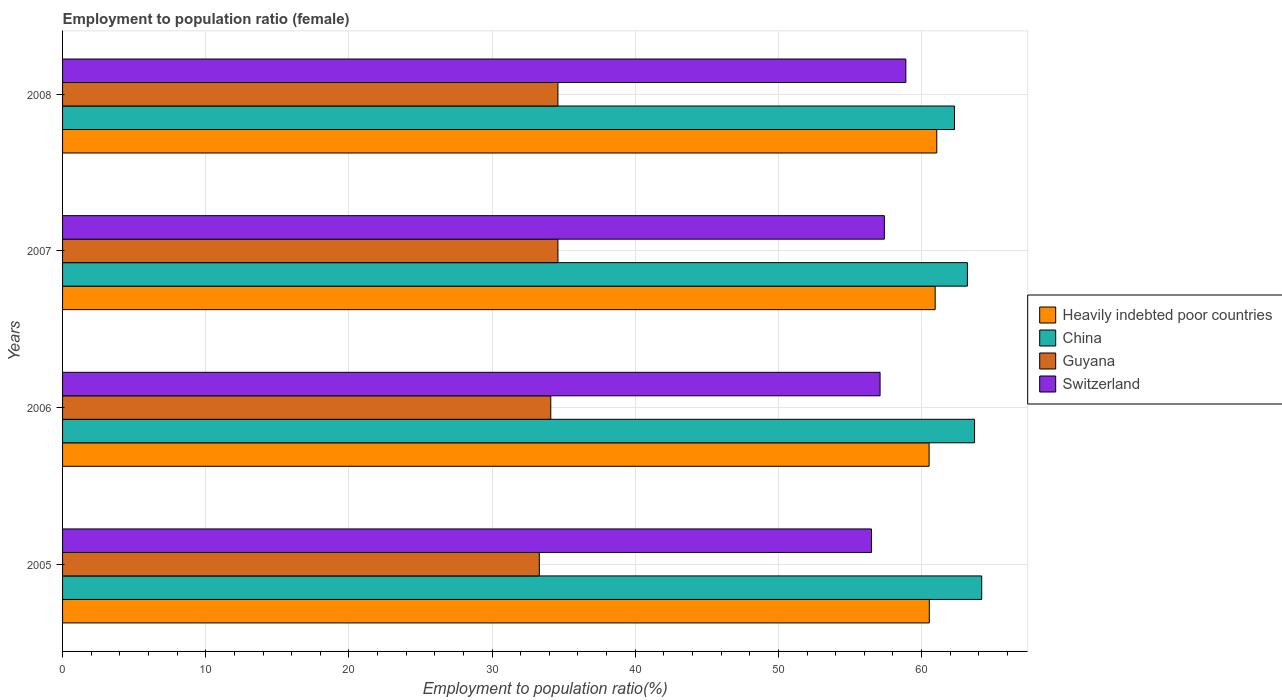How many groups of bars are there?
Provide a short and direct response. 4. Are the number of bars per tick equal to the number of legend labels?
Offer a very short reply. Yes. How many bars are there on the 4th tick from the top?
Your answer should be very brief. 4. What is the employment to population ratio in Guyana in 2007?
Your answer should be very brief. 34.6. Across all years, what is the maximum employment to population ratio in Guyana?
Your answer should be compact. 34.6. Across all years, what is the minimum employment to population ratio in Guyana?
Make the answer very short. 33.3. In which year was the employment to population ratio in Heavily indebted poor countries maximum?
Ensure brevity in your answer.  2008. What is the total employment to population ratio in Switzerland in the graph?
Provide a short and direct response. 229.9. What is the difference between the employment to population ratio in Heavily indebted poor countries in 2005 and that in 2008?
Offer a terse response. -0.52. What is the difference between the employment to population ratio in Guyana in 2005 and the employment to population ratio in Heavily indebted poor countries in 2007?
Ensure brevity in your answer.  -27.65. What is the average employment to population ratio in China per year?
Provide a short and direct response. 63.35. In the year 2007, what is the difference between the employment to population ratio in China and employment to population ratio in Guyana?
Give a very brief answer. 28.6. What is the ratio of the employment to population ratio in Switzerland in 2006 to that in 2007?
Provide a succinct answer. 0.99. Is the employment to population ratio in Guyana in 2006 less than that in 2008?
Make the answer very short. Yes. Is the difference between the employment to population ratio in China in 2006 and 2008 greater than the difference between the employment to population ratio in Guyana in 2006 and 2008?
Provide a short and direct response. Yes. What is the difference between the highest and the second highest employment to population ratio in Heavily indebted poor countries?
Your response must be concise. 0.11. What is the difference between the highest and the lowest employment to population ratio in Switzerland?
Ensure brevity in your answer.  2.4. In how many years, is the employment to population ratio in China greater than the average employment to population ratio in China taken over all years?
Your answer should be compact. 2. Is the sum of the employment to population ratio in China in 2006 and 2008 greater than the maximum employment to population ratio in Heavily indebted poor countries across all years?
Provide a succinct answer. Yes. Is it the case that in every year, the sum of the employment to population ratio in Guyana and employment to population ratio in China is greater than the sum of employment to population ratio in Switzerland and employment to population ratio in Heavily indebted poor countries?
Keep it short and to the point. Yes. What does the 2nd bar from the top in 2008 represents?
Your answer should be compact. Guyana. What does the 4th bar from the bottom in 2008 represents?
Provide a short and direct response. Switzerland. How many bars are there?
Offer a terse response. 16. Are all the bars in the graph horizontal?
Your response must be concise. Yes. How many years are there in the graph?
Provide a short and direct response. 4. Are the values on the major ticks of X-axis written in scientific E-notation?
Give a very brief answer. No. Does the graph contain grids?
Your answer should be very brief. Yes. What is the title of the graph?
Provide a short and direct response. Employment to population ratio (female). What is the label or title of the Y-axis?
Ensure brevity in your answer.  Years. What is the Employment to population ratio(%) of Heavily indebted poor countries in 2005?
Provide a short and direct response. 60.54. What is the Employment to population ratio(%) of China in 2005?
Keep it short and to the point. 64.2. What is the Employment to population ratio(%) of Guyana in 2005?
Your answer should be compact. 33.3. What is the Employment to population ratio(%) of Switzerland in 2005?
Keep it short and to the point. 56.5. What is the Employment to population ratio(%) in Heavily indebted poor countries in 2006?
Make the answer very short. 60.52. What is the Employment to population ratio(%) of China in 2006?
Provide a succinct answer. 63.7. What is the Employment to population ratio(%) of Guyana in 2006?
Ensure brevity in your answer.  34.1. What is the Employment to population ratio(%) in Switzerland in 2006?
Your answer should be compact. 57.1. What is the Employment to population ratio(%) of Heavily indebted poor countries in 2007?
Keep it short and to the point. 60.95. What is the Employment to population ratio(%) in China in 2007?
Your answer should be very brief. 63.2. What is the Employment to population ratio(%) of Guyana in 2007?
Provide a succinct answer. 34.6. What is the Employment to population ratio(%) of Switzerland in 2007?
Offer a very short reply. 57.4. What is the Employment to population ratio(%) in Heavily indebted poor countries in 2008?
Keep it short and to the point. 61.06. What is the Employment to population ratio(%) of China in 2008?
Your answer should be very brief. 62.3. What is the Employment to population ratio(%) of Guyana in 2008?
Give a very brief answer. 34.6. What is the Employment to population ratio(%) of Switzerland in 2008?
Offer a very short reply. 58.9. Across all years, what is the maximum Employment to population ratio(%) of Heavily indebted poor countries?
Offer a terse response. 61.06. Across all years, what is the maximum Employment to population ratio(%) of China?
Ensure brevity in your answer.  64.2. Across all years, what is the maximum Employment to population ratio(%) of Guyana?
Offer a terse response. 34.6. Across all years, what is the maximum Employment to population ratio(%) in Switzerland?
Offer a very short reply. 58.9. Across all years, what is the minimum Employment to population ratio(%) in Heavily indebted poor countries?
Your answer should be compact. 60.52. Across all years, what is the minimum Employment to population ratio(%) in China?
Your response must be concise. 62.3. Across all years, what is the minimum Employment to population ratio(%) in Guyana?
Your answer should be very brief. 33.3. Across all years, what is the minimum Employment to population ratio(%) of Switzerland?
Your answer should be compact. 56.5. What is the total Employment to population ratio(%) of Heavily indebted poor countries in the graph?
Your response must be concise. 243.07. What is the total Employment to population ratio(%) of China in the graph?
Give a very brief answer. 253.4. What is the total Employment to population ratio(%) in Guyana in the graph?
Make the answer very short. 136.6. What is the total Employment to population ratio(%) in Switzerland in the graph?
Offer a terse response. 229.9. What is the difference between the Employment to population ratio(%) in Heavily indebted poor countries in 2005 and that in 2006?
Your answer should be very brief. 0.01. What is the difference between the Employment to population ratio(%) in Guyana in 2005 and that in 2006?
Your response must be concise. -0.8. What is the difference between the Employment to population ratio(%) of Heavily indebted poor countries in 2005 and that in 2007?
Provide a short and direct response. -0.41. What is the difference between the Employment to population ratio(%) in China in 2005 and that in 2007?
Make the answer very short. 1. What is the difference between the Employment to population ratio(%) in Heavily indebted poor countries in 2005 and that in 2008?
Give a very brief answer. -0.52. What is the difference between the Employment to population ratio(%) in China in 2005 and that in 2008?
Provide a succinct answer. 1.9. What is the difference between the Employment to population ratio(%) of Heavily indebted poor countries in 2006 and that in 2007?
Provide a short and direct response. -0.42. What is the difference between the Employment to population ratio(%) in Guyana in 2006 and that in 2007?
Provide a short and direct response. -0.5. What is the difference between the Employment to population ratio(%) of Switzerland in 2006 and that in 2007?
Make the answer very short. -0.3. What is the difference between the Employment to population ratio(%) in Heavily indebted poor countries in 2006 and that in 2008?
Your answer should be compact. -0.54. What is the difference between the Employment to population ratio(%) of Switzerland in 2006 and that in 2008?
Offer a very short reply. -1.8. What is the difference between the Employment to population ratio(%) in Heavily indebted poor countries in 2007 and that in 2008?
Give a very brief answer. -0.11. What is the difference between the Employment to population ratio(%) in Guyana in 2007 and that in 2008?
Give a very brief answer. 0. What is the difference between the Employment to population ratio(%) of Switzerland in 2007 and that in 2008?
Ensure brevity in your answer.  -1.5. What is the difference between the Employment to population ratio(%) in Heavily indebted poor countries in 2005 and the Employment to population ratio(%) in China in 2006?
Offer a terse response. -3.16. What is the difference between the Employment to population ratio(%) in Heavily indebted poor countries in 2005 and the Employment to population ratio(%) in Guyana in 2006?
Keep it short and to the point. 26.44. What is the difference between the Employment to population ratio(%) of Heavily indebted poor countries in 2005 and the Employment to population ratio(%) of Switzerland in 2006?
Make the answer very short. 3.44. What is the difference between the Employment to population ratio(%) of China in 2005 and the Employment to population ratio(%) of Guyana in 2006?
Your response must be concise. 30.1. What is the difference between the Employment to population ratio(%) in China in 2005 and the Employment to population ratio(%) in Switzerland in 2006?
Provide a short and direct response. 7.1. What is the difference between the Employment to population ratio(%) in Guyana in 2005 and the Employment to population ratio(%) in Switzerland in 2006?
Make the answer very short. -23.8. What is the difference between the Employment to population ratio(%) of Heavily indebted poor countries in 2005 and the Employment to population ratio(%) of China in 2007?
Ensure brevity in your answer.  -2.66. What is the difference between the Employment to population ratio(%) of Heavily indebted poor countries in 2005 and the Employment to population ratio(%) of Guyana in 2007?
Offer a very short reply. 25.94. What is the difference between the Employment to population ratio(%) of Heavily indebted poor countries in 2005 and the Employment to population ratio(%) of Switzerland in 2007?
Ensure brevity in your answer.  3.14. What is the difference between the Employment to population ratio(%) of China in 2005 and the Employment to population ratio(%) of Guyana in 2007?
Provide a succinct answer. 29.6. What is the difference between the Employment to population ratio(%) of China in 2005 and the Employment to population ratio(%) of Switzerland in 2007?
Ensure brevity in your answer.  6.8. What is the difference between the Employment to population ratio(%) in Guyana in 2005 and the Employment to population ratio(%) in Switzerland in 2007?
Your response must be concise. -24.1. What is the difference between the Employment to population ratio(%) of Heavily indebted poor countries in 2005 and the Employment to population ratio(%) of China in 2008?
Give a very brief answer. -1.76. What is the difference between the Employment to population ratio(%) in Heavily indebted poor countries in 2005 and the Employment to population ratio(%) in Guyana in 2008?
Offer a very short reply. 25.94. What is the difference between the Employment to population ratio(%) in Heavily indebted poor countries in 2005 and the Employment to population ratio(%) in Switzerland in 2008?
Provide a short and direct response. 1.64. What is the difference between the Employment to population ratio(%) of China in 2005 and the Employment to population ratio(%) of Guyana in 2008?
Give a very brief answer. 29.6. What is the difference between the Employment to population ratio(%) in Guyana in 2005 and the Employment to population ratio(%) in Switzerland in 2008?
Your response must be concise. -25.6. What is the difference between the Employment to population ratio(%) in Heavily indebted poor countries in 2006 and the Employment to population ratio(%) in China in 2007?
Make the answer very short. -2.68. What is the difference between the Employment to population ratio(%) of Heavily indebted poor countries in 2006 and the Employment to population ratio(%) of Guyana in 2007?
Your answer should be compact. 25.92. What is the difference between the Employment to population ratio(%) in Heavily indebted poor countries in 2006 and the Employment to population ratio(%) in Switzerland in 2007?
Your response must be concise. 3.12. What is the difference between the Employment to population ratio(%) in China in 2006 and the Employment to population ratio(%) in Guyana in 2007?
Keep it short and to the point. 29.1. What is the difference between the Employment to population ratio(%) in China in 2006 and the Employment to population ratio(%) in Switzerland in 2007?
Offer a terse response. 6.3. What is the difference between the Employment to population ratio(%) of Guyana in 2006 and the Employment to population ratio(%) of Switzerland in 2007?
Make the answer very short. -23.3. What is the difference between the Employment to population ratio(%) of Heavily indebted poor countries in 2006 and the Employment to population ratio(%) of China in 2008?
Your answer should be compact. -1.78. What is the difference between the Employment to population ratio(%) in Heavily indebted poor countries in 2006 and the Employment to population ratio(%) in Guyana in 2008?
Your answer should be very brief. 25.92. What is the difference between the Employment to population ratio(%) of Heavily indebted poor countries in 2006 and the Employment to population ratio(%) of Switzerland in 2008?
Keep it short and to the point. 1.62. What is the difference between the Employment to population ratio(%) of China in 2006 and the Employment to population ratio(%) of Guyana in 2008?
Offer a terse response. 29.1. What is the difference between the Employment to population ratio(%) in China in 2006 and the Employment to population ratio(%) in Switzerland in 2008?
Your answer should be compact. 4.8. What is the difference between the Employment to population ratio(%) of Guyana in 2006 and the Employment to population ratio(%) of Switzerland in 2008?
Keep it short and to the point. -24.8. What is the difference between the Employment to population ratio(%) in Heavily indebted poor countries in 2007 and the Employment to population ratio(%) in China in 2008?
Make the answer very short. -1.35. What is the difference between the Employment to population ratio(%) of Heavily indebted poor countries in 2007 and the Employment to population ratio(%) of Guyana in 2008?
Offer a very short reply. 26.35. What is the difference between the Employment to population ratio(%) in Heavily indebted poor countries in 2007 and the Employment to population ratio(%) in Switzerland in 2008?
Your answer should be compact. 2.05. What is the difference between the Employment to population ratio(%) of China in 2007 and the Employment to population ratio(%) of Guyana in 2008?
Offer a very short reply. 28.6. What is the difference between the Employment to population ratio(%) in China in 2007 and the Employment to population ratio(%) in Switzerland in 2008?
Provide a short and direct response. 4.3. What is the difference between the Employment to population ratio(%) in Guyana in 2007 and the Employment to population ratio(%) in Switzerland in 2008?
Make the answer very short. -24.3. What is the average Employment to population ratio(%) in Heavily indebted poor countries per year?
Provide a short and direct response. 60.77. What is the average Employment to population ratio(%) of China per year?
Give a very brief answer. 63.35. What is the average Employment to population ratio(%) in Guyana per year?
Make the answer very short. 34.15. What is the average Employment to population ratio(%) in Switzerland per year?
Provide a succinct answer. 57.48. In the year 2005, what is the difference between the Employment to population ratio(%) in Heavily indebted poor countries and Employment to population ratio(%) in China?
Provide a short and direct response. -3.66. In the year 2005, what is the difference between the Employment to population ratio(%) of Heavily indebted poor countries and Employment to population ratio(%) of Guyana?
Ensure brevity in your answer.  27.24. In the year 2005, what is the difference between the Employment to population ratio(%) of Heavily indebted poor countries and Employment to population ratio(%) of Switzerland?
Provide a succinct answer. 4.04. In the year 2005, what is the difference between the Employment to population ratio(%) in China and Employment to population ratio(%) in Guyana?
Offer a terse response. 30.9. In the year 2005, what is the difference between the Employment to population ratio(%) in Guyana and Employment to population ratio(%) in Switzerland?
Provide a short and direct response. -23.2. In the year 2006, what is the difference between the Employment to population ratio(%) of Heavily indebted poor countries and Employment to population ratio(%) of China?
Give a very brief answer. -3.18. In the year 2006, what is the difference between the Employment to population ratio(%) in Heavily indebted poor countries and Employment to population ratio(%) in Guyana?
Your answer should be very brief. 26.42. In the year 2006, what is the difference between the Employment to population ratio(%) of Heavily indebted poor countries and Employment to population ratio(%) of Switzerland?
Keep it short and to the point. 3.42. In the year 2006, what is the difference between the Employment to population ratio(%) of China and Employment to population ratio(%) of Guyana?
Offer a very short reply. 29.6. In the year 2006, what is the difference between the Employment to population ratio(%) of China and Employment to population ratio(%) of Switzerland?
Your answer should be very brief. 6.6. In the year 2007, what is the difference between the Employment to population ratio(%) of Heavily indebted poor countries and Employment to population ratio(%) of China?
Give a very brief answer. -2.25. In the year 2007, what is the difference between the Employment to population ratio(%) of Heavily indebted poor countries and Employment to population ratio(%) of Guyana?
Offer a very short reply. 26.35. In the year 2007, what is the difference between the Employment to population ratio(%) of Heavily indebted poor countries and Employment to population ratio(%) of Switzerland?
Your answer should be compact. 3.55. In the year 2007, what is the difference between the Employment to population ratio(%) in China and Employment to population ratio(%) in Guyana?
Make the answer very short. 28.6. In the year 2007, what is the difference between the Employment to population ratio(%) of Guyana and Employment to population ratio(%) of Switzerland?
Offer a terse response. -22.8. In the year 2008, what is the difference between the Employment to population ratio(%) of Heavily indebted poor countries and Employment to population ratio(%) of China?
Your response must be concise. -1.24. In the year 2008, what is the difference between the Employment to population ratio(%) in Heavily indebted poor countries and Employment to population ratio(%) in Guyana?
Your answer should be compact. 26.46. In the year 2008, what is the difference between the Employment to population ratio(%) in Heavily indebted poor countries and Employment to population ratio(%) in Switzerland?
Your answer should be very brief. 2.16. In the year 2008, what is the difference between the Employment to population ratio(%) in China and Employment to population ratio(%) in Guyana?
Provide a short and direct response. 27.7. In the year 2008, what is the difference between the Employment to population ratio(%) of Guyana and Employment to population ratio(%) of Switzerland?
Your answer should be compact. -24.3. What is the ratio of the Employment to population ratio(%) in China in 2005 to that in 2006?
Make the answer very short. 1.01. What is the ratio of the Employment to population ratio(%) of Guyana in 2005 to that in 2006?
Your answer should be compact. 0.98. What is the ratio of the Employment to population ratio(%) in Switzerland in 2005 to that in 2006?
Your answer should be compact. 0.99. What is the ratio of the Employment to population ratio(%) of China in 2005 to that in 2007?
Your response must be concise. 1.02. What is the ratio of the Employment to population ratio(%) in Guyana in 2005 to that in 2007?
Keep it short and to the point. 0.96. What is the ratio of the Employment to population ratio(%) of Switzerland in 2005 to that in 2007?
Provide a short and direct response. 0.98. What is the ratio of the Employment to population ratio(%) of China in 2005 to that in 2008?
Provide a succinct answer. 1.03. What is the ratio of the Employment to population ratio(%) of Guyana in 2005 to that in 2008?
Your response must be concise. 0.96. What is the ratio of the Employment to population ratio(%) in Switzerland in 2005 to that in 2008?
Make the answer very short. 0.96. What is the ratio of the Employment to population ratio(%) in China in 2006 to that in 2007?
Offer a very short reply. 1.01. What is the ratio of the Employment to population ratio(%) in Guyana in 2006 to that in 2007?
Provide a succinct answer. 0.99. What is the ratio of the Employment to population ratio(%) in Switzerland in 2006 to that in 2007?
Ensure brevity in your answer.  0.99. What is the ratio of the Employment to population ratio(%) in China in 2006 to that in 2008?
Keep it short and to the point. 1.02. What is the ratio of the Employment to population ratio(%) of Guyana in 2006 to that in 2008?
Ensure brevity in your answer.  0.99. What is the ratio of the Employment to population ratio(%) of Switzerland in 2006 to that in 2008?
Make the answer very short. 0.97. What is the ratio of the Employment to population ratio(%) of China in 2007 to that in 2008?
Offer a terse response. 1.01. What is the ratio of the Employment to population ratio(%) of Switzerland in 2007 to that in 2008?
Keep it short and to the point. 0.97. What is the difference between the highest and the second highest Employment to population ratio(%) of Heavily indebted poor countries?
Give a very brief answer. 0.11. What is the difference between the highest and the second highest Employment to population ratio(%) of China?
Give a very brief answer. 0.5. What is the difference between the highest and the lowest Employment to population ratio(%) of Heavily indebted poor countries?
Offer a very short reply. 0.54. What is the difference between the highest and the lowest Employment to population ratio(%) in China?
Ensure brevity in your answer.  1.9. What is the difference between the highest and the lowest Employment to population ratio(%) of Guyana?
Your answer should be very brief. 1.3. What is the difference between the highest and the lowest Employment to population ratio(%) of Switzerland?
Provide a succinct answer. 2.4. 